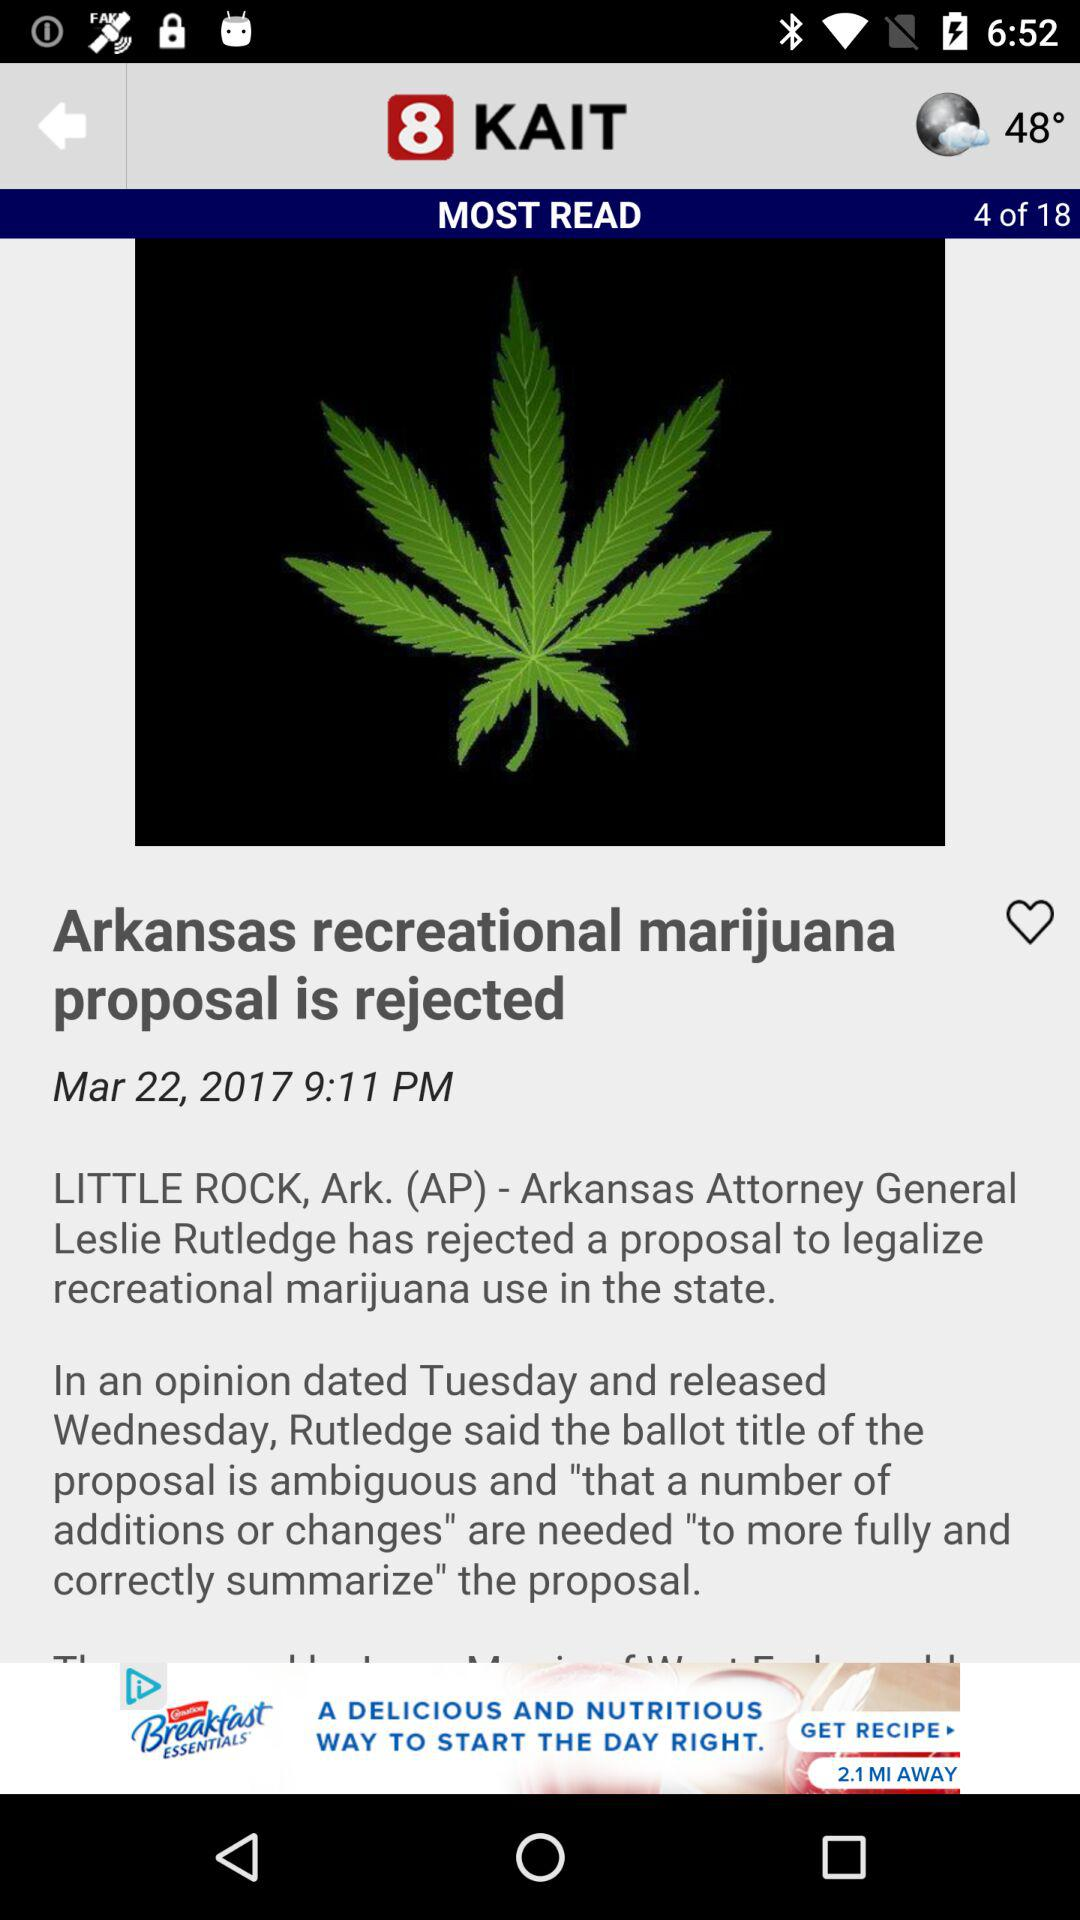What is the date and time? The date is March 22, 2017 and the time is 9:11 PM. 